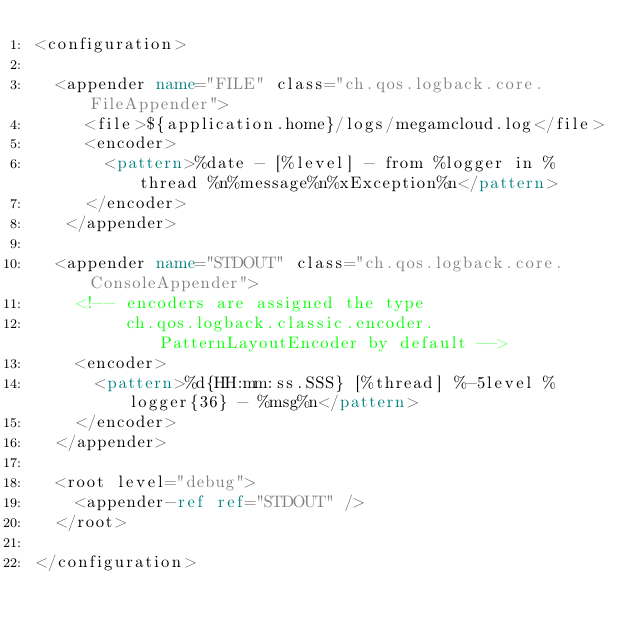Convert code to text. <code><loc_0><loc_0><loc_500><loc_500><_XML_><configuration>   
  
  <appender name="FILE" class="ch.qos.logback.core.FileAppender">
     <file>${application.home}/logs/megamcloud.log</file>
     <encoder>
       <pattern>%date - [%level] - from %logger in %thread %n%message%n%xException%n</pattern>
     </encoder>
   </appender>

  <appender name="STDOUT" class="ch.qos.logback.core.ConsoleAppender">
    <!-- encoders are assigned the type
         ch.qos.logback.classic.encoder.PatternLayoutEncoder by default -->
    <encoder>
      <pattern>%d{HH:mm:ss.SSS} [%thread] %-5level %logger{36} - %msg%n</pattern>
    </encoder>
  </appender>

  <root level="debug">
    <appender-ref ref="STDOUT" />
  </root>
  
</configuration></code> 